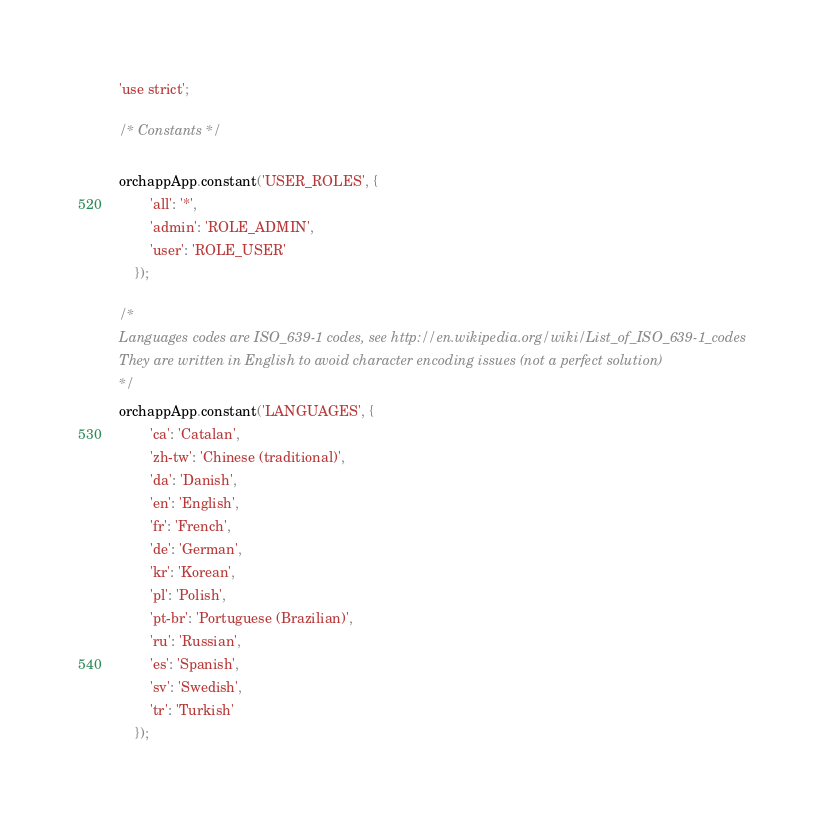<code> <loc_0><loc_0><loc_500><loc_500><_JavaScript_>'use strict';

/* Constants */

orchappApp.constant('USER_ROLES', {
        'all': '*',
        'admin': 'ROLE_ADMIN',
        'user': 'ROLE_USER'
    });

/*
Languages codes are ISO_639-1 codes, see http://en.wikipedia.org/wiki/List_of_ISO_639-1_codes
They are written in English to avoid character encoding issues (not a perfect solution)
*/
orchappApp.constant('LANGUAGES', {
        'ca': 'Catalan',
        'zh-tw': 'Chinese (traditional)',
        'da': 'Danish',
        'en': 'English',
        'fr': 'French',
        'de': 'German',
        'kr': 'Korean',
        'pl': 'Polish',
        'pt-br': 'Portuguese (Brazilian)',
        'ru': 'Russian',
        'es': 'Spanish',
        'sv': 'Swedish',
        'tr': 'Turkish'
    });
</code> 